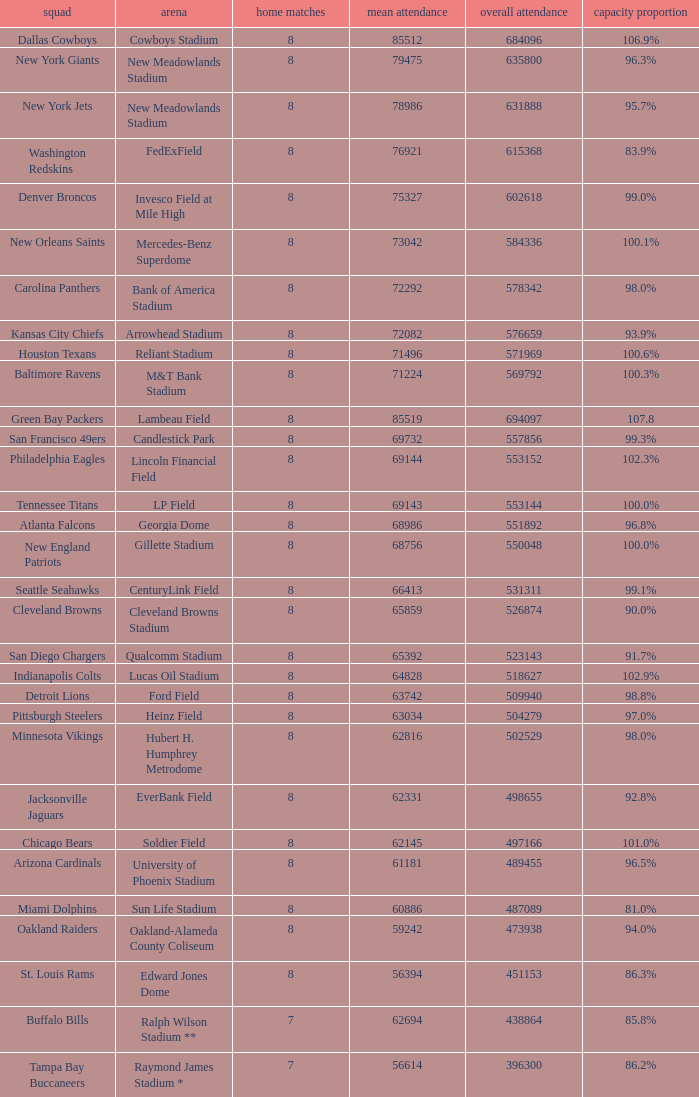What is the number listed in home games when the team is Seattle Seahawks? 8.0. 